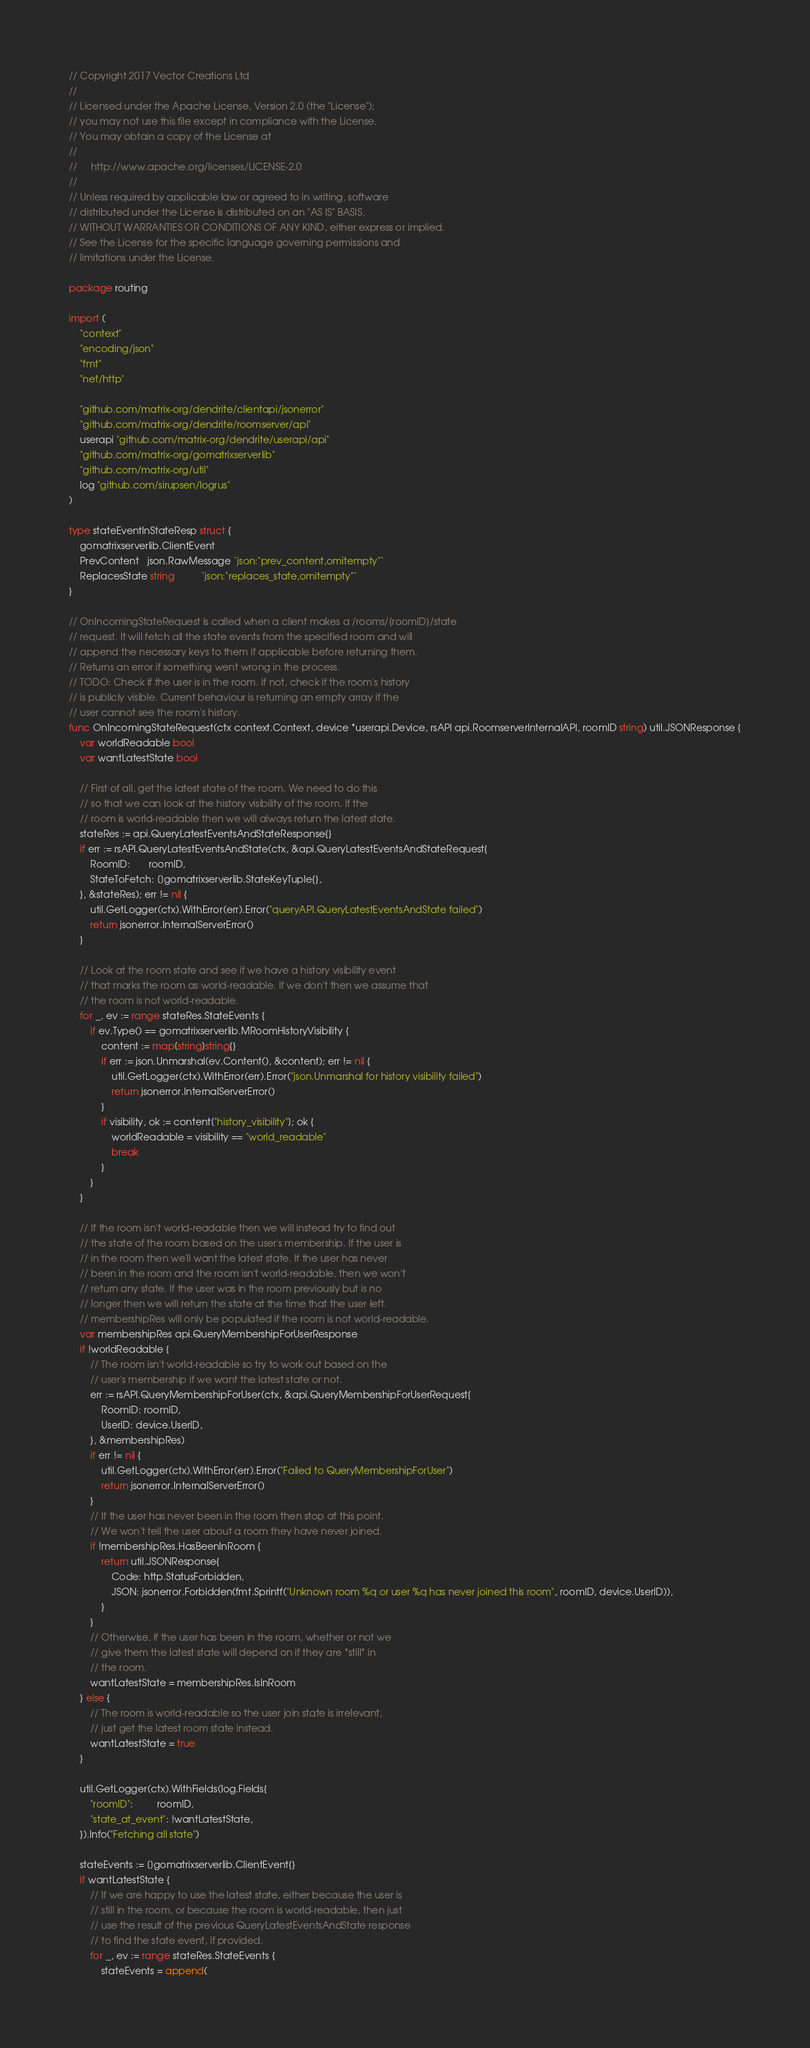<code> <loc_0><loc_0><loc_500><loc_500><_Go_>// Copyright 2017 Vector Creations Ltd
//
// Licensed under the Apache License, Version 2.0 (the "License");
// you may not use this file except in compliance with the License.
// You may obtain a copy of the License at
//
//     http://www.apache.org/licenses/LICENSE-2.0
//
// Unless required by applicable law or agreed to in writing, software
// distributed under the License is distributed on an "AS IS" BASIS,
// WITHOUT WARRANTIES OR CONDITIONS OF ANY KIND, either express or implied.
// See the License for the specific language governing permissions and
// limitations under the License.

package routing

import (
	"context"
	"encoding/json"
	"fmt"
	"net/http"

	"github.com/matrix-org/dendrite/clientapi/jsonerror"
	"github.com/matrix-org/dendrite/roomserver/api"
	userapi "github.com/matrix-org/dendrite/userapi/api"
	"github.com/matrix-org/gomatrixserverlib"
	"github.com/matrix-org/util"
	log "github.com/sirupsen/logrus"
)

type stateEventInStateResp struct {
	gomatrixserverlib.ClientEvent
	PrevContent   json.RawMessage `json:"prev_content,omitempty"`
	ReplacesState string          `json:"replaces_state,omitempty"`
}

// OnIncomingStateRequest is called when a client makes a /rooms/{roomID}/state
// request. It will fetch all the state events from the specified room and will
// append the necessary keys to them if applicable before returning them.
// Returns an error if something went wrong in the process.
// TODO: Check if the user is in the room. If not, check if the room's history
// is publicly visible. Current behaviour is returning an empty array if the
// user cannot see the room's history.
func OnIncomingStateRequest(ctx context.Context, device *userapi.Device, rsAPI api.RoomserverInternalAPI, roomID string) util.JSONResponse {
	var worldReadable bool
	var wantLatestState bool

	// First of all, get the latest state of the room. We need to do this
	// so that we can look at the history visibility of the room. If the
	// room is world-readable then we will always return the latest state.
	stateRes := api.QueryLatestEventsAndStateResponse{}
	if err := rsAPI.QueryLatestEventsAndState(ctx, &api.QueryLatestEventsAndStateRequest{
		RoomID:       roomID,
		StateToFetch: []gomatrixserverlib.StateKeyTuple{},
	}, &stateRes); err != nil {
		util.GetLogger(ctx).WithError(err).Error("queryAPI.QueryLatestEventsAndState failed")
		return jsonerror.InternalServerError()
	}

	// Look at the room state and see if we have a history visibility event
	// that marks the room as world-readable. If we don't then we assume that
	// the room is not world-readable.
	for _, ev := range stateRes.StateEvents {
		if ev.Type() == gomatrixserverlib.MRoomHistoryVisibility {
			content := map[string]string{}
			if err := json.Unmarshal(ev.Content(), &content); err != nil {
				util.GetLogger(ctx).WithError(err).Error("json.Unmarshal for history visibility failed")
				return jsonerror.InternalServerError()
			}
			if visibility, ok := content["history_visibility"]; ok {
				worldReadable = visibility == "world_readable"
				break
			}
		}
	}

	// If the room isn't world-readable then we will instead try to find out
	// the state of the room based on the user's membership. If the user is
	// in the room then we'll want the latest state. If the user has never
	// been in the room and the room isn't world-readable, then we won't
	// return any state. If the user was in the room previously but is no
	// longer then we will return the state at the time that the user left.
	// membershipRes will only be populated if the room is not world-readable.
	var membershipRes api.QueryMembershipForUserResponse
	if !worldReadable {
		// The room isn't world-readable so try to work out based on the
		// user's membership if we want the latest state or not.
		err := rsAPI.QueryMembershipForUser(ctx, &api.QueryMembershipForUserRequest{
			RoomID: roomID,
			UserID: device.UserID,
		}, &membershipRes)
		if err != nil {
			util.GetLogger(ctx).WithError(err).Error("Failed to QueryMembershipForUser")
			return jsonerror.InternalServerError()
		}
		// If the user has never been in the room then stop at this point.
		// We won't tell the user about a room they have never joined.
		if !membershipRes.HasBeenInRoom {
			return util.JSONResponse{
				Code: http.StatusForbidden,
				JSON: jsonerror.Forbidden(fmt.Sprintf("Unknown room %q or user %q has never joined this room", roomID, device.UserID)),
			}
		}
		// Otherwise, if the user has been in the room, whether or not we
		// give them the latest state will depend on if they are *still* in
		// the room.
		wantLatestState = membershipRes.IsInRoom
	} else {
		// The room is world-readable so the user join state is irrelevant,
		// just get the latest room state instead.
		wantLatestState = true
	}

	util.GetLogger(ctx).WithFields(log.Fields{
		"roomID":         roomID,
		"state_at_event": !wantLatestState,
	}).Info("Fetching all state")

	stateEvents := []gomatrixserverlib.ClientEvent{}
	if wantLatestState {
		// If we are happy to use the latest state, either because the user is
		// still in the room, or because the room is world-readable, then just
		// use the result of the previous QueryLatestEventsAndState response
		// to find the state event, if provided.
		for _, ev := range stateRes.StateEvents {
			stateEvents = append(</code> 